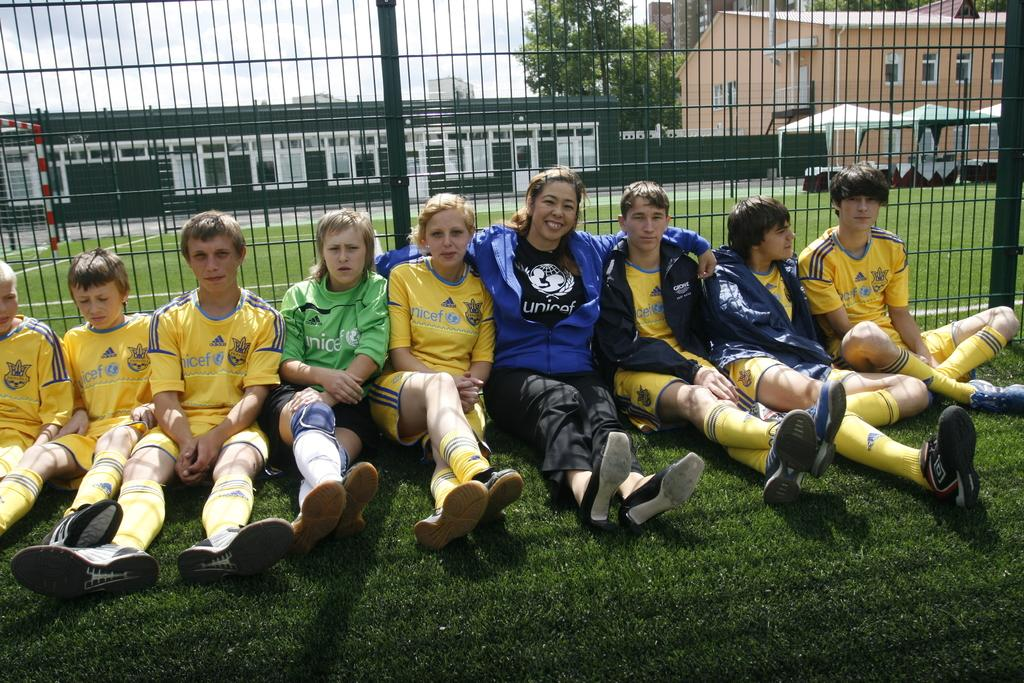How many people are in the image? There is a group of people in the image, but the exact number is not specified. What are the people doing in the image? The people are sitting on the grass in the image. What can be seen in the background of the image? There are buildings, fencing, trees, some objects, and the sky visible in the background of the image. What is the acoustics like in the downtown area depicted in the image? There is no mention of downtown or acoustics in the image; it features a group of people sitting on the grass with various background elements. 